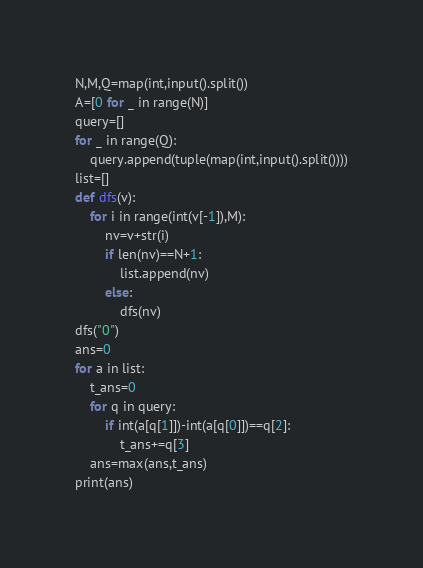Convert code to text. <code><loc_0><loc_0><loc_500><loc_500><_Python_>N,M,Q=map(int,input().split())
A=[0 for _ in range(N)]
query=[]
for _ in range(Q):
    query.append(tuple(map(int,input().split())))
list=[]
def dfs(v):
    for i in range(int(v[-1]),M):
        nv=v+str(i)
        if len(nv)==N+1:
            list.append(nv)
        else:
            dfs(nv)
dfs("0")
ans=0
for a in list:
    t_ans=0
    for q in query:
        if int(a[q[1]])-int(a[q[0]])==q[2]:
            t_ans+=q[3]
    ans=max(ans,t_ans)
print(ans)</code> 